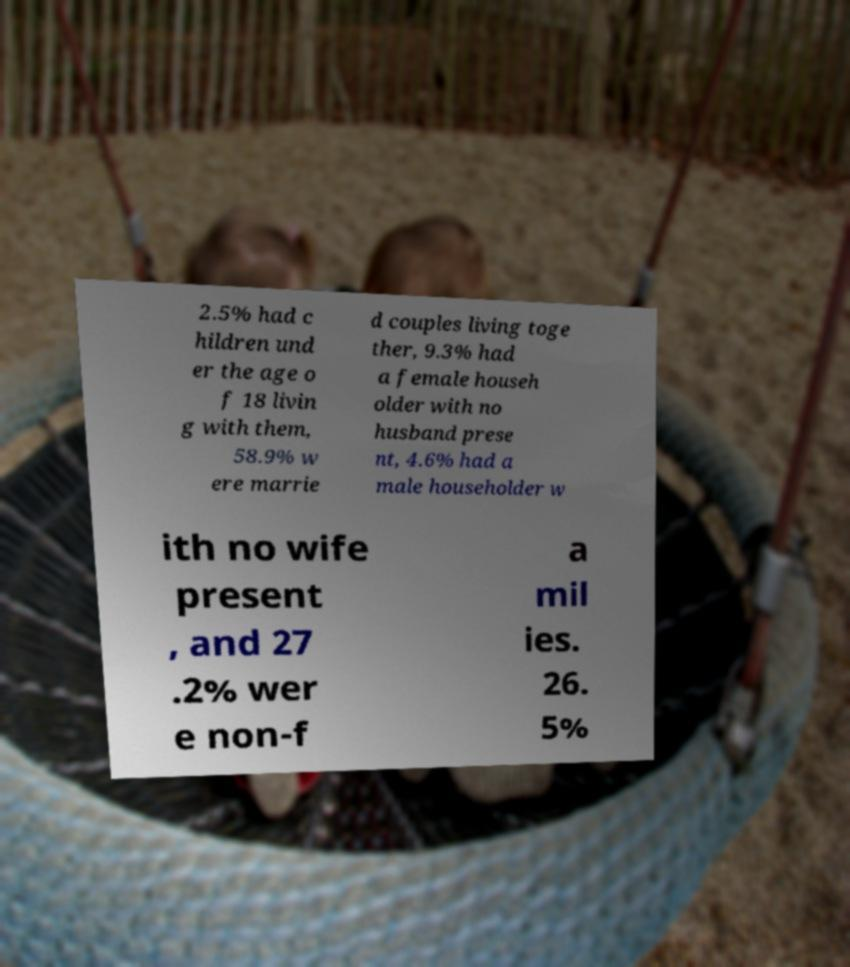There's text embedded in this image that I need extracted. Can you transcribe it verbatim? 2.5% had c hildren und er the age o f 18 livin g with them, 58.9% w ere marrie d couples living toge ther, 9.3% had a female househ older with no husband prese nt, 4.6% had a male householder w ith no wife present , and 27 .2% wer e non-f a mil ies. 26. 5% 